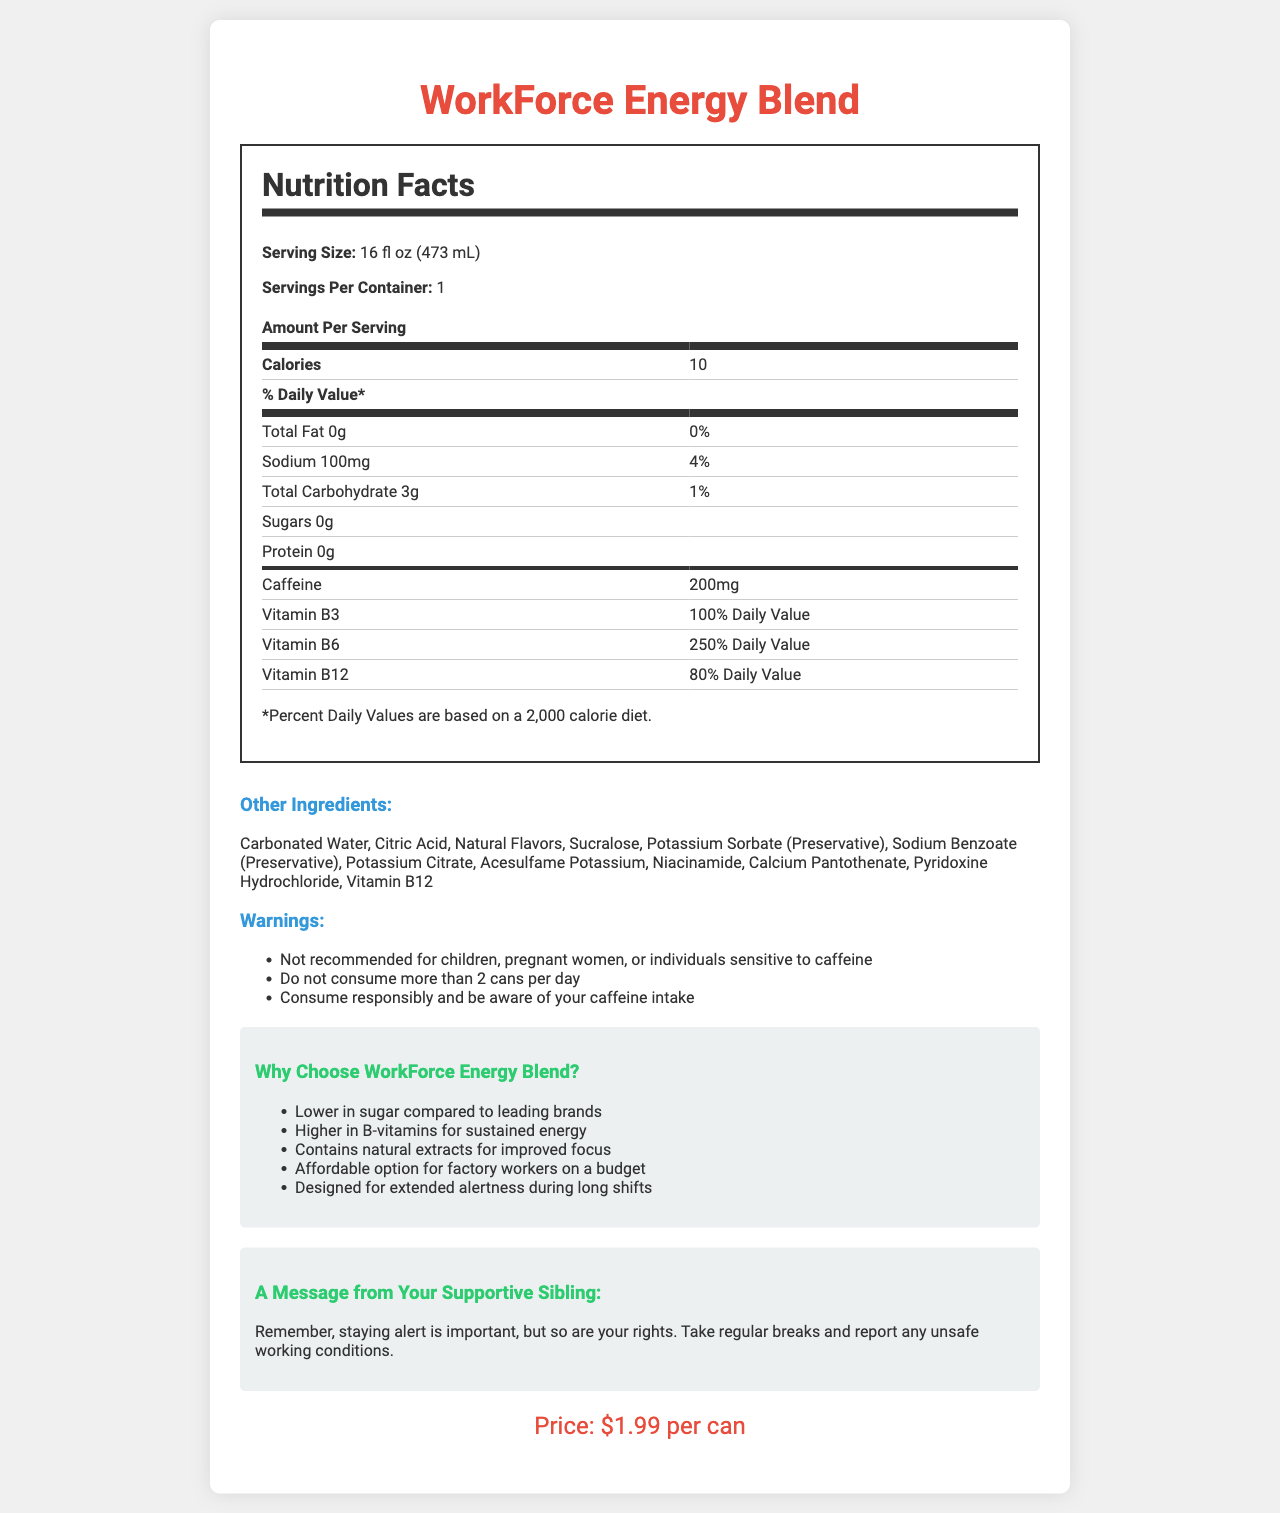what is the serving size of WorkForce Energy Blend? The serving size is listed under "Serving Size" in the Nutrition Facts section.
Answer: 16 fl oz (473 mL) how many calories are in one serving? The calories per serving are listed as 10 in the Nutrition Facts section.
Answer: 10 what percentage of the daily value of Vitamin B6 does WorkForce Energy Blend provide? The Vitamin B6 content is listed under the Nutrition Facts section as 250% Daily Value.
Answer: 250% Daily Value How much caffeine is in a serving of WorkForce Energy Blend? The amount of caffeine per serving is explicitly mentioned under the Nutrition Facts section.
Answer: 200mg how much sodium does one serving contain? The sodium content is listed in the Nutrition Facts section as 100mg.
Answer: 100mg How many servings are there per container of WorkForce Energy Blend? A. 1 B. 2 C. 3 D. 4 The document specifies under "Servings Per Container" that there is 1 serving per container.
Answer: A What is the price of one can of WorkForce Energy Blend? 1. $0.99 2. $1.99 3. $2.99 4. $3.99 The price is mentioned towards the end of the document as $1.99 per can.
Answer: 2 Does WorkForce Energy Blend contain any sugar? The sugar content is listed as 0g in the Nutrition Facts section.
Answer: No Can children consume this energy drink? The document includes a warning that the product is not recommended for children, listed in the Warnings section.
Answer: No Summarize the main purpose of this document. The document outlines the nutritional facts, additional ingredients, and warnings for WorkForce Energy Blend. It also highlights the advantages of choosing this drink, especially for factory workers, and emphasizes the importance of worker rights and safety.
Answer: The document provides detailed nutritional information and reasons for choosing WorkForce Energy Blend, including its benefits for sustained energy during long shifts, all while reminding workers of their rights. How much Inositol does WorkForce Energy Blend contain per serving? The content of Inositol per serving is listed in the document under the Nutrition Facts section.
Answer: 100mg Which ingredient serves as a preservative in WorkForce Energy Blend? A. Carbonated Water B. Citric Acid C. Sodium Benzoate D. Calcium Pantothenate Sodium Benzoate is listed as a preservative in the ingredient list of the document.
Answer: C Does WorkForce Energy Blend have more total fat or protein? Both total fat and protein contents are listed as 0g, so they are equal.
Answer: Protein What are the consequences of consuming more than 2 cans per day? The document advises not to consume more than 2 cans per day but doesn't specify any direct consequences. Not enough detailed information is provided.
Answer: Not stated Based on the comparison notes, why might factory workers prefer WorkForce Energy Blend over other brands? The comparison notes section lists these points as the reasons why WorkForce Energy Blend is beneficial for factory workers.
Answer: Because it is lower in sugar, higher in B-vitamins, contains natural extracts for focus, is affordable, and designed for extended alertness. 